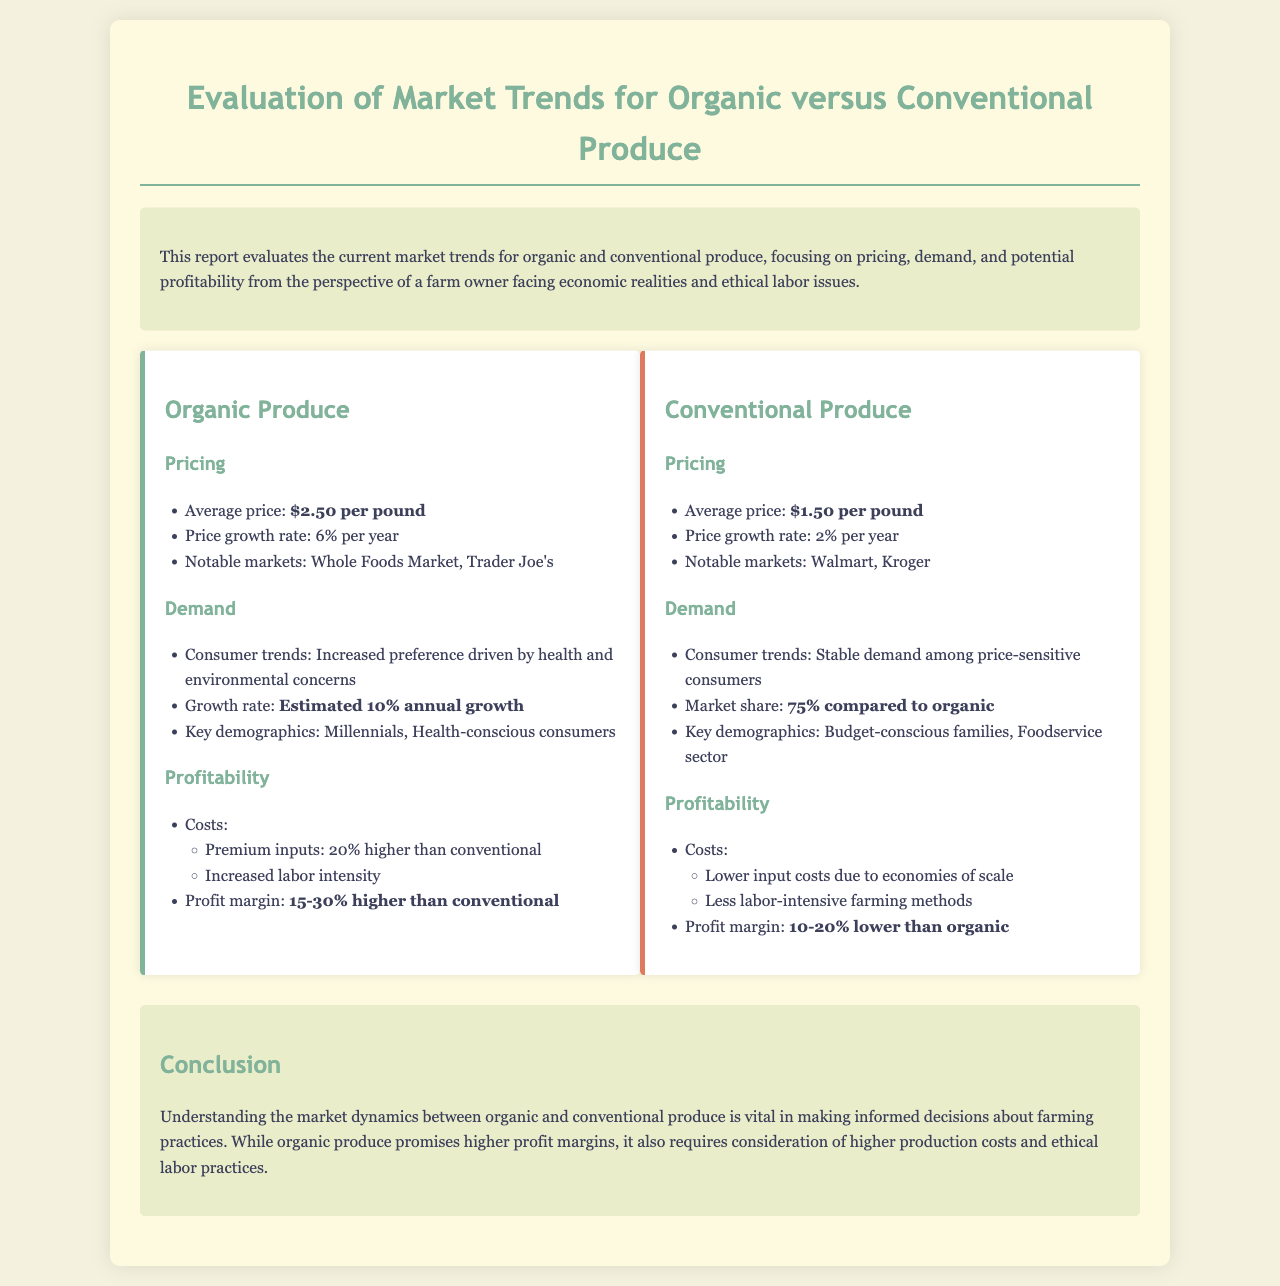what is the average price of organic produce? The average price of organic produce is mentioned directly in the document as $2.50 per pound.
Answer: $2.50 per pound what is the growth rate for conventional produce prices? The growth rate for conventional produce prices is provided in the document as 2% per year.
Answer: 2% per year which retail markets are notable for organic produce? The document lists notable markets for organic produce as Whole Foods Market and Trader Joe's.
Answer: Whole Foods Market, Trader Joe's what is the estimated annual growth rate for organic produce demand? The estimated annual growth rate for organic produce demand is highlighted in the document as 10%.
Answer: 10% how much higher are premium inputs for organic compared to conventional? The report states that premium inputs for organic are 20% higher than conventional.
Answer: 20% higher what percentage of market share does conventional produce hold compared to organic? The market share for conventional produce compared to organic is specified as 75% in the document.
Answer: 75% what is the profit margin range for organic produce? The profit margin range for organic produce is stated in the document as 15-30% higher than conventional.
Answer: 15-30% higher what consumer trend influences organic produce demand? The document mentions that health and environmental concerns drive consumer trends for organic produce.
Answer: health and environmental concerns what are the key demographics for conventional produce? The document identifies budget-conscious families and the foodservice sector as key demographics for conventional produce.
Answer: Budget-conscious families, Foodservice sector 